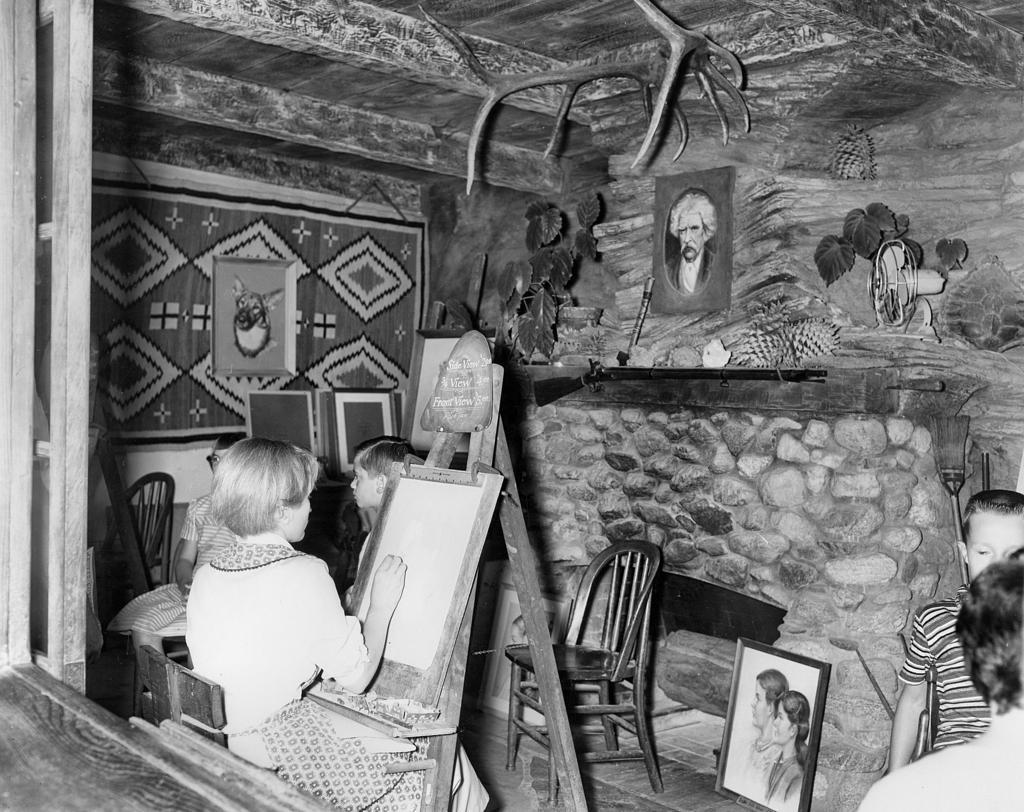Could you give a brief overview of what you see in this image? In the picture we can see a woman sitting on the chair and drawing some thing on the white board which is on the stand, there is one more boy next to the board watching something, in the background we can see a boy, chair, walls, paintings, and a person. 